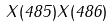Convert formula to latex. <formula><loc_0><loc_0><loc_500><loc_500>X ( 4 8 5 ) X ( 4 8 6 )</formula> 